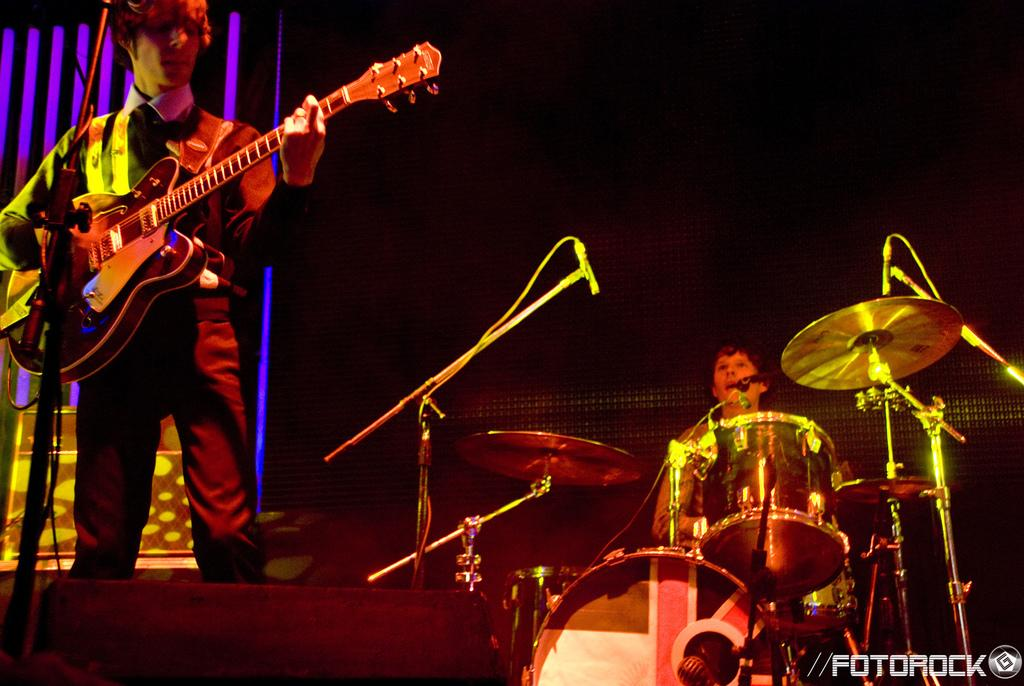What is the person on the stage doing? The person is standing on a stage and holding a guitar. Can you describe the other person on the stage? There is a man on the right side of the stage who is playing electronic drums. What instrument is the person on the stage holding? The person on the stage is holding a guitar. What type of thought can be seen on the table in the image? There is no table or thought present in the image. What is the cork used for in the image? There is no cork present in the image. 